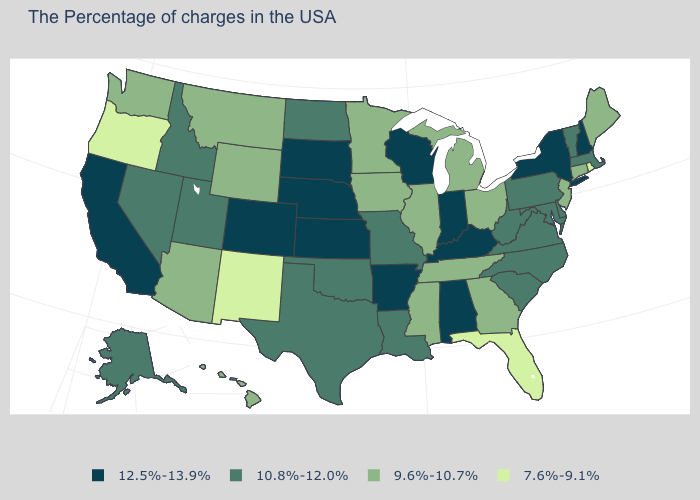Name the states that have a value in the range 12.5%-13.9%?
Write a very short answer. New Hampshire, New York, Kentucky, Indiana, Alabama, Wisconsin, Arkansas, Kansas, Nebraska, South Dakota, Colorado, California. Name the states that have a value in the range 7.6%-9.1%?
Concise answer only. Rhode Island, Florida, New Mexico, Oregon. Is the legend a continuous bar?
Quick response, please. No. What is the value of Washington?
Answer briefly. 9.6%-10.7%. What is the highest value in the USA?
Quick response, please. 12.5%-13.9%. What is the value of Georgia?
Give a very brief answer. 9.6%-10.7%. What is the value of Colorado?
Write a very short answer. 12.5%-13.9%. Among the states that border Washington , which have the highest value?
Keep it brief. Idaho. Name the states that have a value in the range 10.8%-12.0%?
Quick response, please. Massachusetts, Vermont, Delaware, Maryland, Pennsylvania, Virginia, North Carolina, South Carolina, West Virginia, Louisiana, Missouri, Oklahoma, Texas, North Dakota, Utah, Idaho, Nevada, Alaska. What is the highest value in the USA?
Quick response, please. 12.5%-13.9%. Which states have the lowest value in the MidWest?
Give a very brief answer. Ohio, Michigan, Illinois, Minnesota, Iowa. Among the states that border Kansas , which have the lowest value?
Keep it brief. Missouri, Oklahoma. Does California have the highest value in the West?
Give a very brief answer. Yes. Does the map have missing data?
Be succinct. No. What is the value of Virginia?
Write a very short answer. 10.8%-12.0%. 